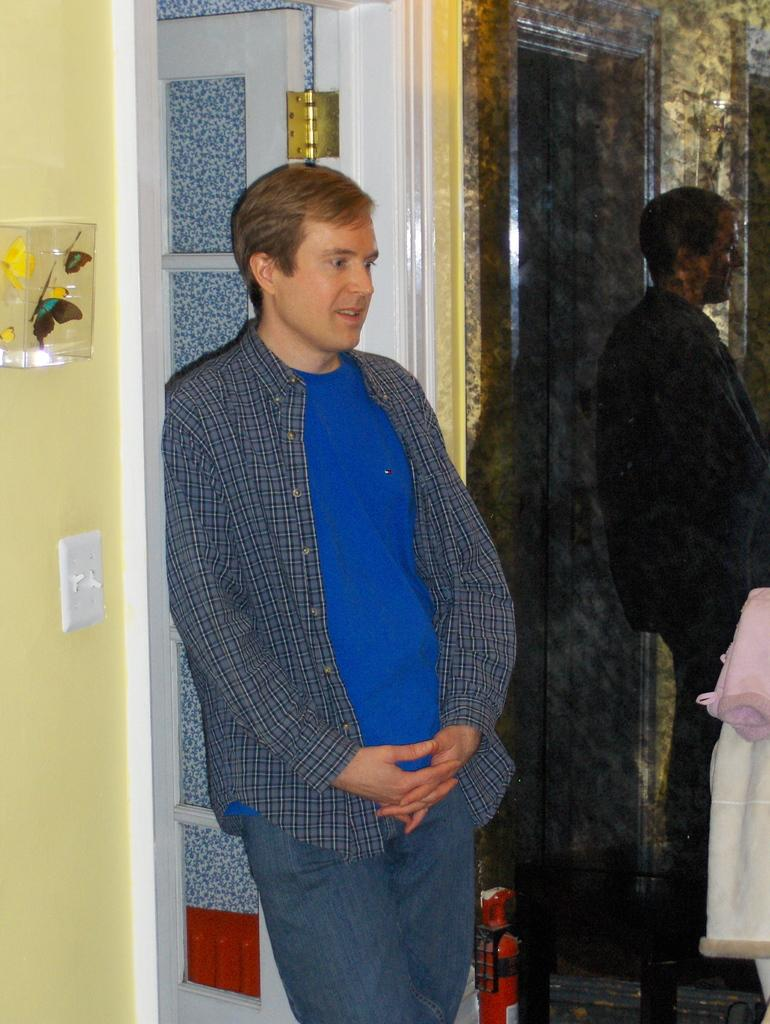How many people are in the image? There are two men standing in the image. What can be seen in the image besides the men? Clothes, a fire extinguisher, butterflies, a switchboard, a wall, and some objects are visible in the image. What might be used in case of a fire emergency in the image? A fire extinguisher is present in the image. What type of living organisms can be seen in the image? Butterflies are visible in the image. What is the background of the image? There is a wall in the background of the image, along with some objects. What type of bread can be seen in the image? There is no bread present in the image. What section of the library are the men in the image located? There is no library present in the image, so it is not possible to determine which section the men are in. 